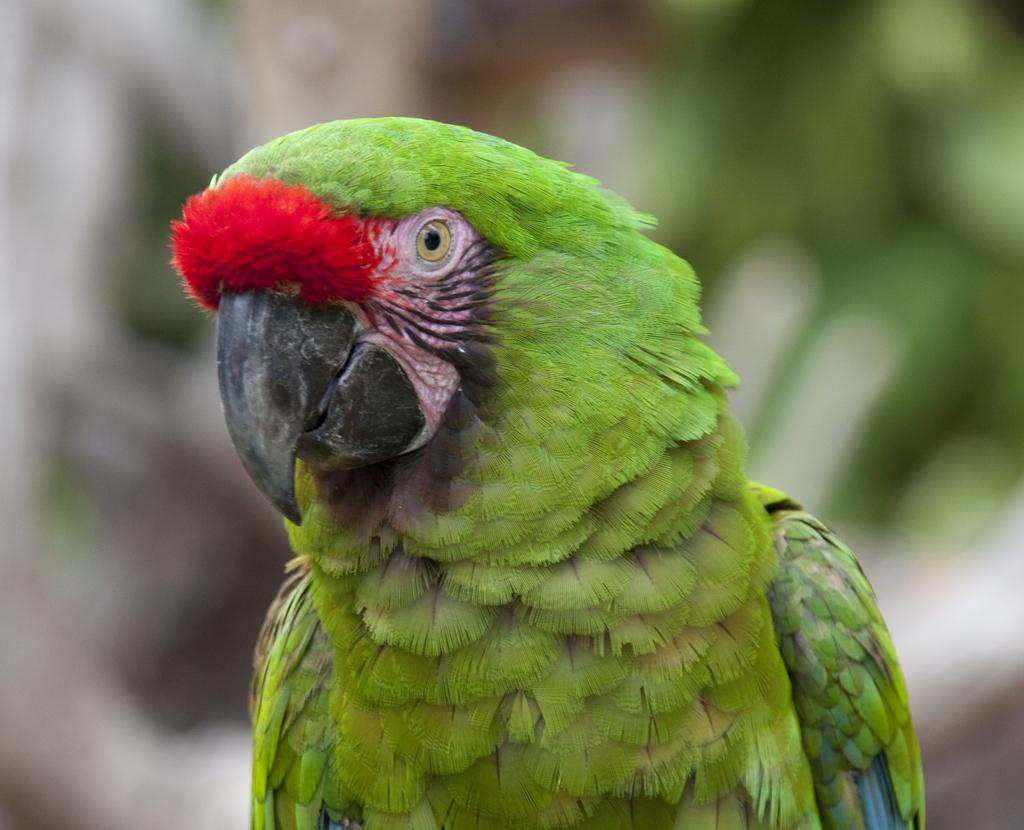What type of animal is in the image? There is a parrot in the image. How would you describe the background of the image? The background of the image is blurred. Can you identify any objects in the background? Yes, there are objects visible in the background. What type of impulse can be seen affecting the parrot in the image? There is no impulse affecting the parrot in the image; it is a still image. What type of straw is the parrot using to rest in the image? There is no straw present in the image, and the parrot is not shown resting. 